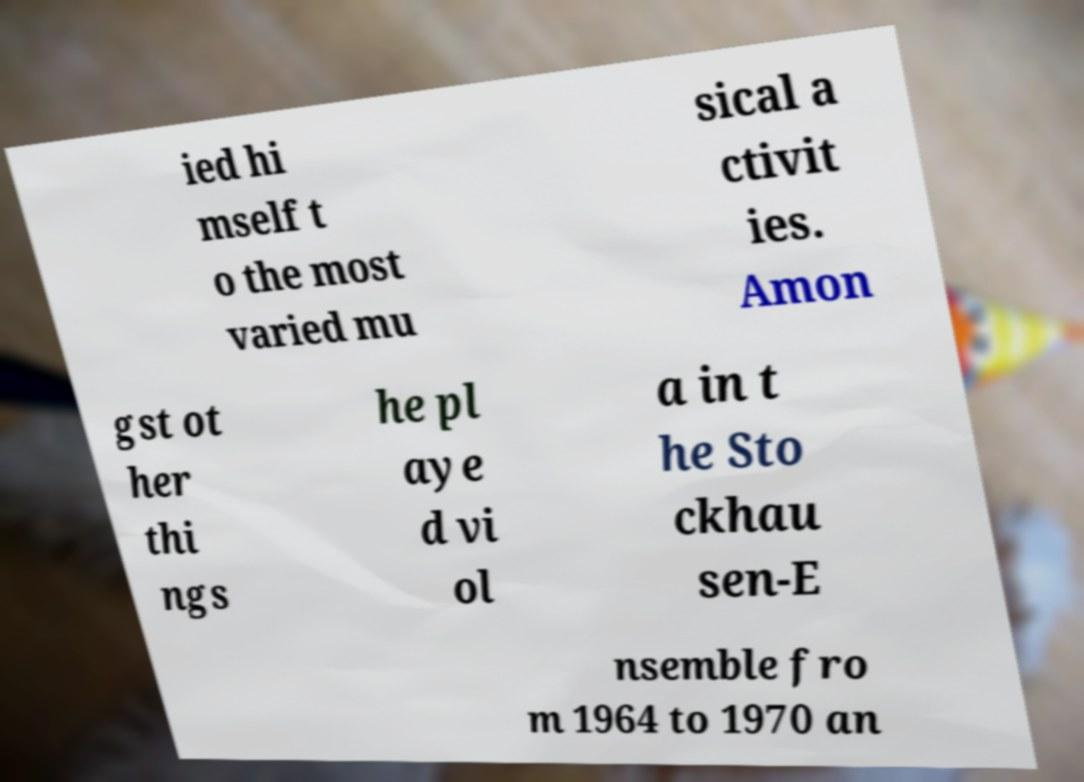I need the written content from this picture converted into text. Can you do that? ied hi mself t o the most varied mu sical a ctivit ies. Amon gst ot her thi ngs he pl aye d vi ol a in t he Sto ckhau sen-E nsemble fro m 1964 to 1970 an 